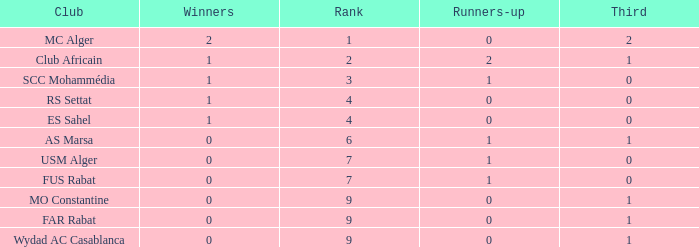How many Winners have a Third of 1, and Runners-up smaller than 0? 0.0. 